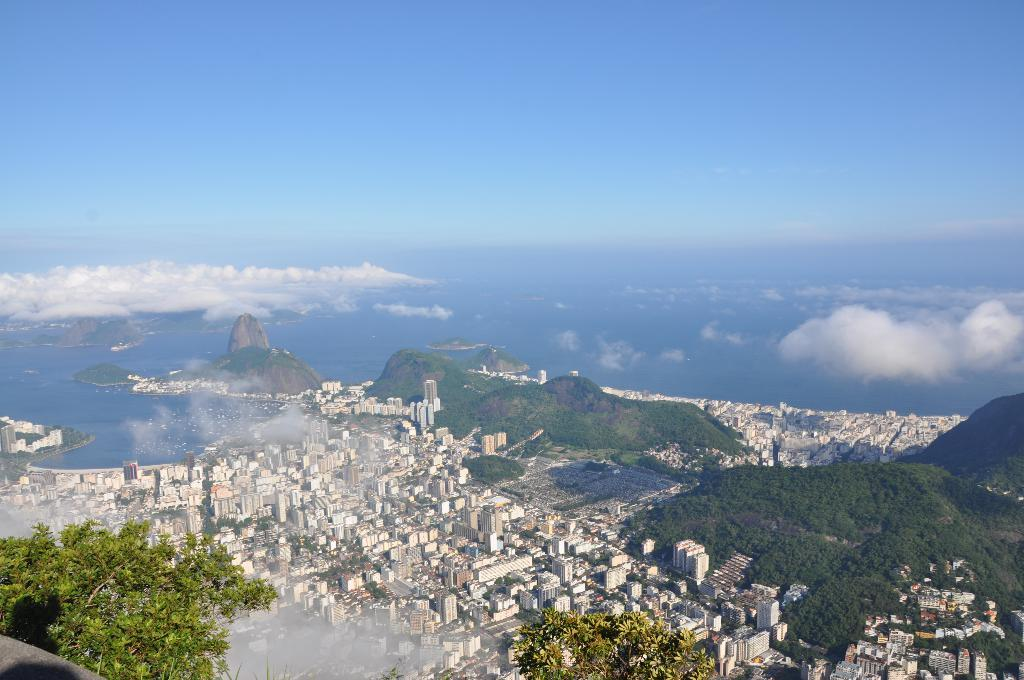What type of view is shown in the image? The image is an aerial view of a city. What structures can be seen in the image? There are buildings in the image. What type of vegetation is present in the image? Trees are present in the image, and there are also hills with grass. Are there any natural elements visible in the image? Yes, plants and water are visible in the image. What can be seen in the background of the image? Clouds and the sky are present in the background of the image. What type of class is being taught in the image? There is no class or teaching activity present in the image. What type of maid is visible in the image? There is no maid present in the image. 